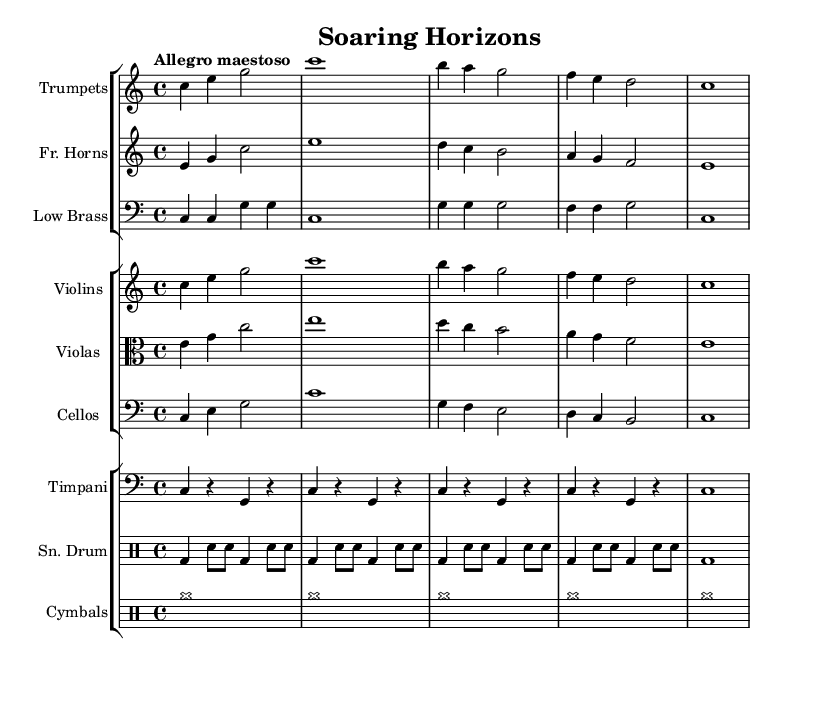What is the key signature of this music? The key signature is C major, which has no sharps or flats indicated at the start of the staff.
Answer: C major What is the time signature of this music? The time signature is 4/4, which is indicated at the beginning of the piece, showing that there are four beats in each measure.
Answer: 4/4 What is the tempo marking for this piece? The tempo marking is "Allegro maestoso," which is written above the staff, indicating a fast and dignified tempo.
Answer: Allegro maestoso How many measures are in the first section for the trumpets? Counting the measures indicated in the trumpet part, the first section contains 5 measures.
Answer: 5 Which instruments are playing in unison in the opening measures? Observing the opening measures, the trumpets and violins are playing the same melodic line together, indicating they are in unison.
Answer: Trumpets and Violins What is the dynamic marking for the cymbals? The dynamic marking for the cymbals is marked as "cymr," indicating that they should play at a crescendo and maintain a strong presence throughout.
Answer: cymr What is the rhythm pattern used by the snare drum? The snare drum has a consistent pattern of bass drum strikes and snare hits, with each measure following the pattern of two bass drum hits followed by snare taps.
Answer: bd4 sn8 sn 